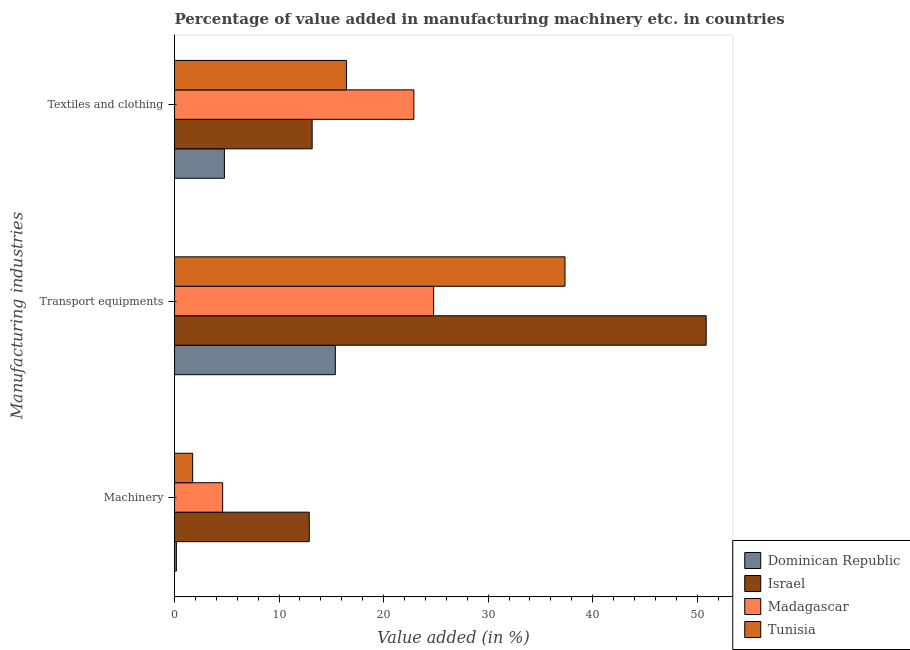How many groups of bars are there?
Your response must be concise. 3. How many bars are there on the 3rd tick from the bottom?
Make the answer very short. 4. What is the label of the 3rd group of bars from the top?
Offer a terse response. Machinery. What is the value added in manufacturing textile and clothing in Israel?
Make the answer very short. 13.17. Across all countries, what is the maximum value added in manufacturing textile and clothing?
Your answer should be compact. 22.9. Across all countries, what is the minimum value added in manufacturing textile and clothing?
Ensure brevity in your answer.  4.77. In which country was the value added in manufacturing textile and clothing minimum?
Provide a short and direct response. Dominican Republic. What is the total value added in manufacturing machinery in the graph?
Your answer should be very brief. 19.4. What is the difference between the value added in manufacturing machinery in Dominican Republic and that in Israel?
Your answer should be compact. -12.71. What is the difference between the value added in manufacturing textile and clothing in Dominican Republic and the value added in manufacturing transport equipments in Israel?
Keep it short and to the point. -46.09. What is the average value added in manufacturing transport equipments per country?
Give a very brief answer. 32.1. What is the difference between the value added in manufacturing transport equipments and value added in manufacturing machinery in Madagascar?
Keep it short and to the point. 20.19. In how many countries, is the value added in manufacturing transport equipments greater than 34 %?
Provide a short and direct response. 2. What is the ratio of the value added in manufacturing transport equipments in Dominican Republic to that in Israel?
Make the answer very short. 0.3. Is the value added in manufacturing textile and clothing in Dominican Republic less than that in Israel?
Your response must be concise. Yes. Is the difference between the value added in manufacturing textile and clothing in Israel and Tunisia greater than the difference between the value added in manufacturing machinery in Israel and Tunisia?
Make the answer very short. No. What is the difference between the highest and the second highest value added in manufacturing machinery?
Make the answer very short. 8.29. What is the difference between the highest and the lowest value added in manufacturing textile and clothing?
Ensure brevity in your answer.  18.13. In how many countries, is the value added in manufacturing transport equipments greater than the average value added in manufacturing transport equipments taken over all countries?
Ensure brevity in your answer.  2. What does the 1st bar from the top in Textiles and clothing represents?
Offer a terse response. Tunisia. What does the 2nd bar from the bottom in Transport equipments represents?
Offer a very short reply. Israel. Are all the bars in the graph horizontal?
Make the answer very short. Yes. How many countries are there in the graph?
Offer a terse response. 4. What is the difference between two consecutive major ticks on the X-axis?
Your response must be concise. 10. Where does the legend appear in the graph?
Your answer should be very brief. Bottom right. What is the title of the graph?
Keep it short and to the point. Percentage of value added in manufacturing machinery etc. in countries. Does "Turks and Caicos Islands" appear as one of the legend labels in the graph?
Your answer should be very brief. No. What is the label or title of the X-axis?
Your answer should be compact. Value added (in %). What is the label or title of the Y-axis?
Make the answer very short. Manufacturing industries. What is the Value added (in %) of Dominican Republic in Machinery?
Offer a very short reply. 0.18. What is the Value added (in %) of Israel in Machinery?
Your answer should be compact. 12.89. What is the Value added (in %) of Madagascar in Machinery?
Provide a short and direct response. 4.6. What is the Value added (in %) in Tunisia in Machinery?
Offer a terse response. 1.73. What is the Value added (in %) in Dominican Republic in Transport equipments?
Your answer should be very brief. 15.38. What is the Value added (in %) in Israel in Transport equipments?
Ensure brevity in your answer.  50.86. What is the Value added (in %) in Madagascar in Transport equipments?
Give a very brief answer. 24.79. What is the Value added (in %) in Tunisia in Transport equipments?
Your answer should be very brief. 37.36. What is the Value added (in %) of Dominican Republic in Textiles and clothing?
Your response must be concise. 4.77. What is the Value added (in %) in Israel in Textiles and clothing?
Your answer should be very brief. 13.17. What is the Value added (in %) in Madagascar in Textiles and clothing?
Ensure brevity in your answer.  22.9. What is the Value added (in %) in Tunisia in Textiles and clothing?
Offer a terse response. 16.45. Across all Manufacturing industries, what is the maximum Value added (in %) of Dominican Republic?
Your response must be concise. 15.38. Across all Manufacturing industries, what is the maximum Value added (in %) in Israel?
Provide a short and direct response. 50.86. Across all Manufacturing industries, what is the maximum Value added (in %) of Madagascar?
Provide a succinct answer. 24.79. Across all Manufacturing industries, what is the maximum Value added (in %) of Tunisia?
Provide a short and direct response. 37.36. Across all Manufacturing industries, what is the minimum Value added (in %) in Dominican Republic?
Provide a succinct answer. 0.18. Across all Manufacturing industries, what is the minimum Value added (in %) in Israel?
Offer a terse response. 12.89. Across all Manufacturing industries, what is the minimum Value added (in %) in Madagascar?
Make the answer very short. 4.6. Across all Manufacturing industries, what is the minimum Value added (in %) of Tunisia?
Make the answer very short. 1.73. What is the total Value added (in %) of Dominican Republic in the graph?
Your answer should be compact. 20.33. What is the total Value added (in %) of Israel in the graph?
Your answer should be very brief. 76.92. What is the total Value added (in %) in Madagascar in the graph?
Provide a short and direct response. 52.29. What is the total Value added (in %) in Tunisia in the graph?
Make the answer very short. 55.53. What is the difference between the Value added (in %) in Dominican Republic in Machinery and that in Transport equipments?
Provide a short and direct response. -15.21. What is the difference between the Value added (in %) of Israel in Machinery and that in Transport equipments?
Your answer should be very brief. -37.98. What is the difference between the Value added (in %) in Madagascar in Machinery and that in Transport equipments?
Give a very brief answer. -20.19. What is the difference between the Value added (in %) of Tunisia in Machinery and that in Transport equipments?
Your response must be concise. -35.62. What is the difference between the Value added (in %) in Dominican Republic in Machinery and that in Textiles and clothing?
Provide a short and direct response. -4.59. What is the difference between the Value added (in %) of Israel in Machinery and that in Textiles and clothing?
Make the answer very short. -0.28. What is the difference between the Value added (in %) in Madagascar in Machinery and that in Textiles and clothing?
Your answer should be compact. -18.3. What is the difference between the Value added (in %) in Tunisia in Machinery and that in Textiles and clothing?
Provide a short and direct response. -14.71. What is the difference between the Value added (in %) in Dominican Republic in Transport equipments and that in Textiles and clothing?
Offer a very short reply. 10.61. What is the difference between the Value added (in %) of Israel in Transport equipments and that in Textiles and clothing?
Your answer should be very brief. 37.7. What is the difference between the Value added (in %) in Madagascar in Transport equipments and that in Textiles and clothing?
Offer a terse response. 1.89. What is the difference between the Value added (in %) of Tunisia in Transport equipments and that in Textiles and clothing?
Your answer should be very brief. 20.91. What is the difference between the Value added (in %) of Dominican Republic in Machinery and the Value added (in %) of Israel in Transport equipments?
Give a very brief answer. -50.69. What is the difference between the Value added (in %) of Dominican Republic in Machinery and the Value added (in %) of Madagascar in Transport equipments?
Provide a succinct answer. -24.61. What is the difference between the Value added (in %) in Dominican Republic in Machinery and the Value added (in %) in Tunisia in Transport equipments?
Provide a short and direct response. -37.18. What is the difference between the Value added (in %) in Israel in Machinery and the Value added (in %) in Madagascar in Transport equipments?
Give a very brief answer. -11.9. What is the difference between the Value added (in %) of Israel in Machinery and the Value added (in %) of Tunisia in Transport equipments?
Provide a short and direct response. -24.47. What is the difference between the Value added (in %) in Madagascar in Machinery and the Value added (in %) in Tunisia in Transport equipments?
Make the answer very short. -32.75. What is the difference between the Value added (in %) in Dominican Republic in Machinery and the Value added (in %) in Israel in Textiles and clothing?
Offer a very short reply. -12.99. What is the difference between the Value added (in %) in Dominican Republic in Machinery and the Value added (in %) in Madagascar in Textiles and clothing?
Provide a succinct answer. -22.72. What is the difference between the Value added (in %) in Dominican Republic in Machinery and the Value added (in %) in Tunisia in Textiles and clothing?
Keep it short and to the point. -16.27. What is the difference between the Value added (in %) of Israel in Machinery and the Value added (in %) of Madagascar in Textiles and clothing?
Make the answer very short. -10.01. What is the difference between the Value added (in %) in Israel in Machinery and the Value added (in %) in Tunisia in Textiles and clothing?
Your response must be concise. -3.56. What is the difference between the Value added (in %) of Madagascar in Machinery and the Value added (in %) of Tunisia in Textiles and clothing?
Provide a short and direct response. -11.84. What is the difference between the Value added (in %) in Dominican Republic in Transport equipments and the Value added (in %) in Israel in Textiles and clothing?
Offer a terse response. 2.22. What is the difference between the Value added (in %) of Dominican Republic in Transport equipments and the Value added (in %) of Madagascar in Textiles and clothing?
Provide a short and direct response. -7.51. What is the difference between the Value added (in %) in Dominican Republic in Transport equipments and the Value added (in %) in Tunisia in Textiles and clothing?
Keep it short and to the point. -1.06. What is the difference between the Value added (in %) of Israel in Transport equipments and the Value added (in %) of Madagascar in Textiles and clothing?
Give a very brief answer. 27.96. What is the difference between the Value added (in %) of Israel in Transport equipments and the Value added (in %) of Tunisia in Textiles and clothing?
Provide a succinct answer. 34.42. What is the difference between the Value added (in %) of Madagascar in Transport equipments and the Value added (in %) of Tunisia in Textiles and clothing?
Keep it short and to the point. 8.34. What is the average Value added (in %) of Dominican Republic per Manufacturing industries?
Ensure brevity in your answer.  6.78. What is the average Value added (in %) of Israel per Manufacturing industries?
Provide a succinct answer. 25.64. What is the average Value added (in %) in Madagascar per Manufacturing industries?
Provide a short and direct response. 17.43. What is the average Value added (in %) of Tunisia per Manufacturing industries?
Your answer should be compact. 18.51. What is the difference between the Value added (in %) of Dominican Republic and Value added (in %) of Israel in Machinery?
Your answer should be compact. -12.71. What is the difference between the Value added (in %) of Dominican Republic and Value added (in %) of Madagascar in Machinery?
Your answer should be very brief. -4.43. What is the difference between the Value added (in %) of Dominican Republic and Value added (in %) of Tunisia in Machinery?
Provide a short and direct response. -1.55. What is the difference between the Value added (in %) of Israel and Value added (in %) of Madagascar in Machinery?
Make the answer very short. 8.29. What is the difference between the Value added (in %) in Israel and Value added (in %) in Tunisia in Machinery?
Your answer should be very brief. 11.16. What is the difference between the Value added (in %) of Madagascar and Value added (in %) of Tunisia in Machinery?
Ensure brevity in your answer.  2.87. What is the difference between the Value added (in %) of Dominican Republic and Value added (in %) of Israel in Transport equipments?
Give a very brief answer. -35.48. What is the difference between the Value added (in %) of Dominican Republic and Value added (in %) of Madagascar in Transport equipments?
Give a very brief answer. -9.41. What is the difference between the Value added (in %) in Dominican Republic and Value added (in %) in Tunisia in Transport equipments?
Make the answer very short. -21.97. What is the difference between the Value added (in %) in Israel and Value added (in %) in Madagascar in Transport equipments?
Your answer should be very brief. 26.07. What is the difference between the Value added (in %) of Israel and Value added (in %) of Tunisia in Transport equipments?
Offer a terse response. 13.51. What is the difference between the Value added (in %) of Madagascar and Value added (in %) of Tunisia in Transport equipments?
Ensure brevity in your answer.  -12.57. What is the difference between the Value added (in %) in Dominican Republic and Value added (in %) in Israel in Textiles and clothing?
Provide a short and direct response. -8.4. What is the difference between the Value added (in %) of Dominican Republic and Value added (in %) of Madagascar in Textiles and clothing?
Give a very brief answer. -18.13. What is the difference between the Value added (in %) in Dominican Republic and Value added (in %) in Tunisia in Textiles and clothing?
Ensure brevity in your answer.  -11.68. What is the difference between the Value added (in %) in Israel and Value added (in %) in Madagascar in Textiles and clothing?
Offer a very short reply. -9.73. What is the difference between the Value added (in %) of Israel and Value added (in %) of Tunisia in Textiles and clothing?
Make the answer very short. -3.28. What is the difference between the Value added (in %) in Madagascar and Value added (in %) in Tunisia in Textiles and clothing?
Your answer should be very brief. 6.45. What is the ratio of the Value added (in %) of Dominican Republic in Machinery to that in Transport equipments?
Your response must be concise. 0.01. What is the ratio of the Value added (in %) in Israel in Machinery to that in Transport equipments?
Make the answer very short. 0.25. What is the ratio of the Value added (in %) in Madagascar in Machinery to that in Transport equipments?
Provide a short and direct response. 0.19. What is the ratio of the Value added (in %) in Tunisia in Machinery to that in Transport equipments?
Provide a short and direct response. 0.05. What is the ratio of the Value added (in %) in Dominican Republic in Machinery to that in Textiles and clothing?
Provide a short and direct response. 0.04. What is the ratio of the Value added (in %) in Israel in Machinery to that in Textiles and clothing?
Offer a terse response. 0.98. What is the ratio of the Value added (in %) of Madagascar in Machinery to that in Textiles and clothing?
Provide a short and direct response. 0.2. What is the ratio of the Value added (in %) in Tunisia in Machinery to that in Textiles and clothing?
Your response must be concise. 0.11. What is the ratio of the Value added (in %) of Dominican Republic in Transport equipments to that in Textiles and clothing?
Make the answer very short. 3.22. What is the ratio of the Value added (in %) of Israel in Transport equipments to that in Textiles and clothing?
Your response must be concise. 3.86. What is the ratio of the Value added (in %) in Madagascar in Transport equipments to that in Textiles and clothing?
Provide a short and direct response. 1.08. What is the ratio of the Value added (in %) in Tunisia in Transport equipments to that in Textiles and clothing?
Keep it short and to the point. 2.27. What is the difference between the highest and the second highest Value added (in %) in Dominican Republic?
Your answer should be very brief. 10.61. What is the difference between the highest and the second highest Value added (in %) of Israel?
Provide a succinct answer. 37.7. What is the difference between the highest and the second highest Value added (in %) of Madagascar?
Keep it short and to the point. 1.89. What is the difference between the highest and the second highest Value added (in %) of Tunisia?
Offer a terse response. 20.91. What is the difference between the highest and the lowest Value added (in %) in Dominican Republic?
Offer a very short reply. 15.21. What is the difference between the highest and the lowest Value added (in %) in Israel?
Your answer should be compact. 37.98. What is the difference between the highest and the lowest Value added (in %) of Madagascar?
Offer a terse response. 20.19. What is the difference between the highest and the lowest Value added (in %) of Tunisia?
Your answer should be very brief. 35.62. 